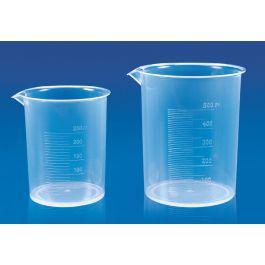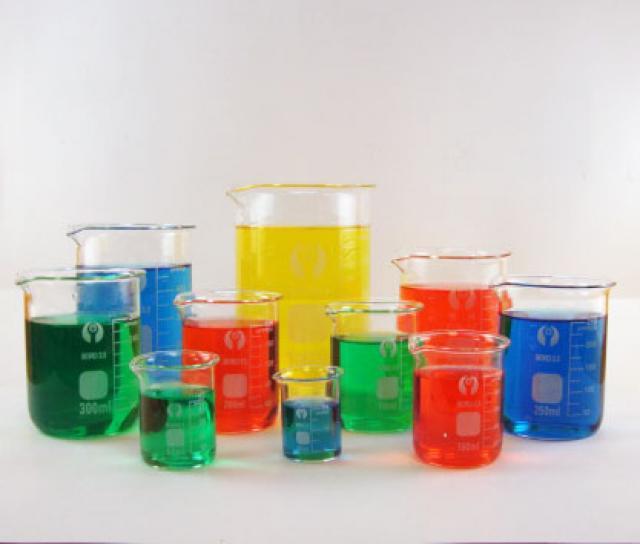The first image is the image on the left, the second image is the image on the right. For the images shown, is this caption "The containers in the left image are empty." true? Answer yes or no. Yes. The first image is the image on the left, the second image is the image on the right. For the images shown, is this caption "At least one of the containers in one of the images is empty." true? Answer yes or no. Yes. 